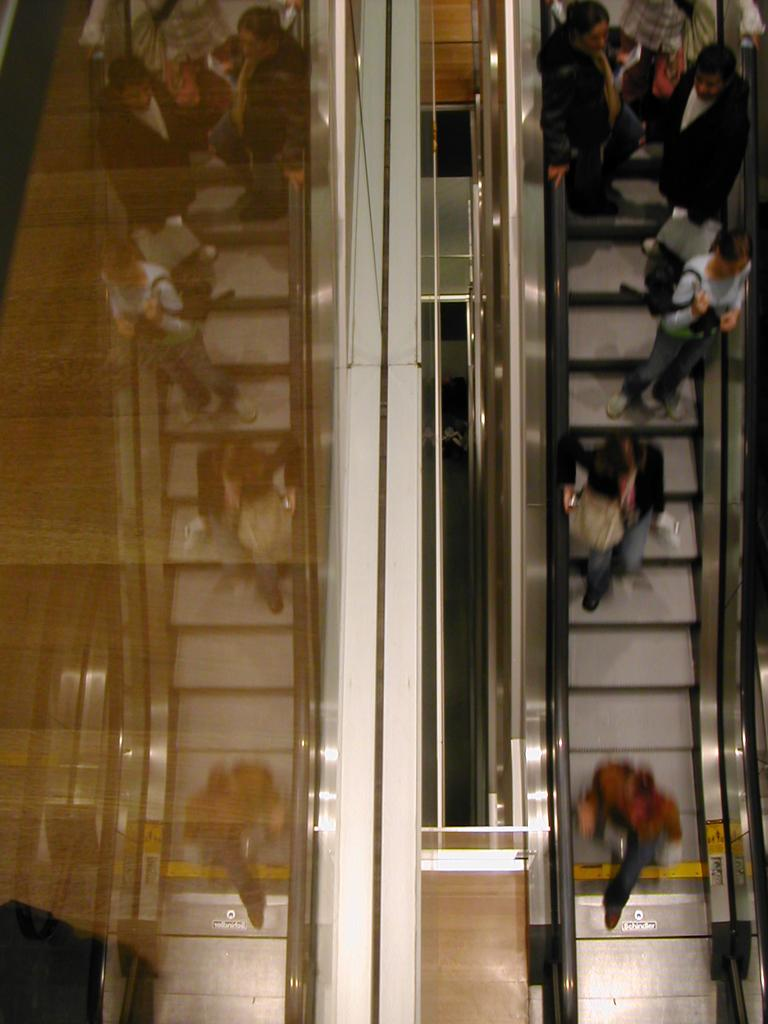What are the people in the image doing? The people in the image are standing on an escalator. What are some of the people holding? Some of the people are holding bags. What object in the image allows people to see their reflections? There is a mirror in the image. Can you see the people's reflections in the mirror? Yes, the people's reflections are visible in the mirror. What type of lunch is being served on the ground in the image? There is no lunch or ground present in the image; it features people standing on an escalator and a mirror. 